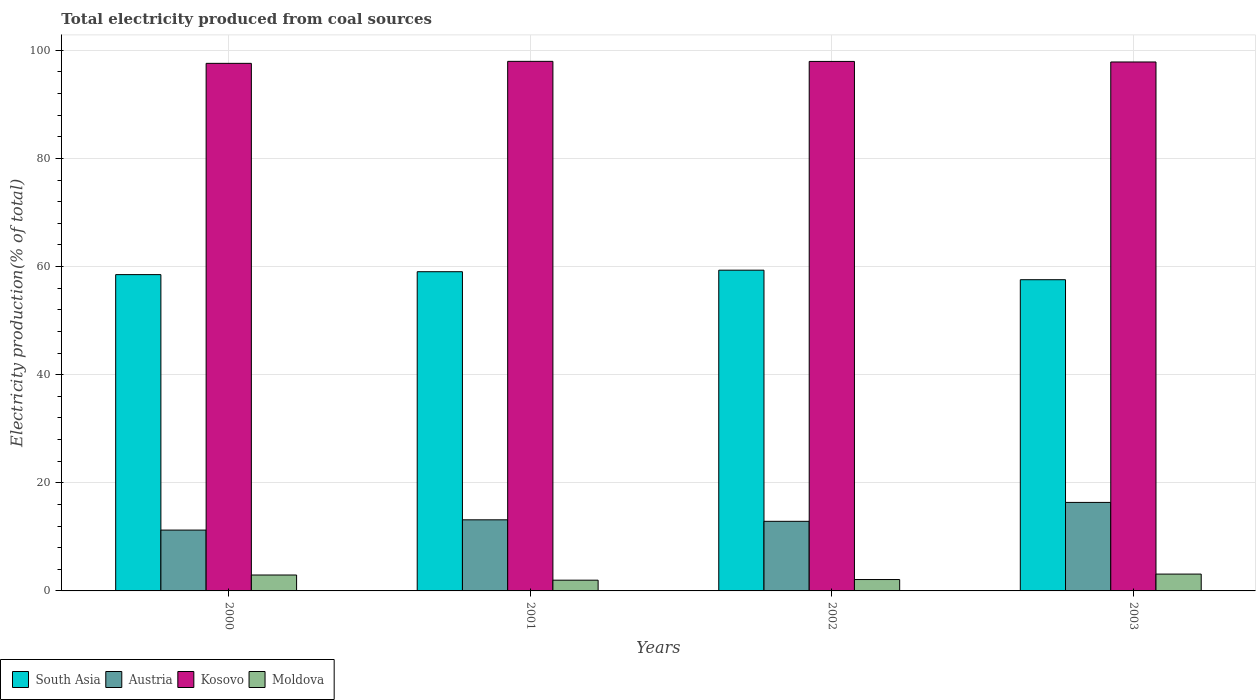How many different coloured bars are there?
Offer a terse response. 4. How many groups of bars are there?
Keep it short and to the point. 4. Are the number of bars on each tick of the X-axis equal?
Your response must be concise. Yes. How many bars are there on the 2nd tick from the left?
Provide a short and direct response. 4. How many bars are there on the 3rd tick from the right?
Offer a very short reply. 4. What is the total electricity produced in Kosovo in 2001?
Your answer should be very brief. 97.97. Across all years, what is the maximum total electricity produced in Kosovo?
Your response must be concise. 97.97. Across all years, what is the minimum total electricity produced in Moldova?
Your answer should be very brief. 1.99. In which year was the total electricity produced in Kosovo minimum?
Offer a very short reply. 2000. What is the total total electricity produced in Kosovo in the graph?
Your answer should be compact. 391.37. What is the difference between the total electricity produced in South Asia in 2000 and that in 2003?
Ensure brevity in your answer.  0.95. What is the difference between the total electricity produced in South Asia in 2003 and the total electricity produced in Austria in 2001?
Provide a short and direct response. 44.42. What is the average total electricity produced in Kosovo per year?
Keep it short and to the point. 97.84. In the year 2000, what is the difference between the total electricity produced in Kosovo and total electricity produced in South Asia?
Provide a succinct answer. 39.08. What is the ratio of the total electricity produced in Moldova in 2000 to that in 2003?
Give a very brief answer. 0.94. What is the difference between the highest and the second highest total electricity produced in South Asia?
Provide a short and direct response. 0.28. What is the difference between the highest and the lowest total electricity produced in Austria?
Make the answer very short. 5.12. In how many years, is the total electricity produced in South Asia greater than the average total electricity produced in South Asia taken over all years?
Offer a very short reply. 2. Is the sum of the total electricity produced in Austria in 2000 and 2002 greater than the maximum total electricity produced in Moldova across all years?
Your answer should be compact. Yes. Is it the case that in every year, the sum of the total electricity produced in South Asia and total electricity produced in Kosovo is greater than the sum of total electricity produced in Austria and total electricity produced in Moldova?
Your response must be concise. Yes. What does the 1st bar from the right in 2003 represents?
Ensure brevity in your answer.  Moldova. What is the difference between two consecutive major ticks on the Y-axis?
Offer a terse response. 20. Are the values on the major ticks of Y-axis written in scientific E-notation?
Your answer should be very brief. No. Does the graph contain any zero values?
Your answer should be compact. No. Where does the legend appear in the graph?
Provide a short and direct response. Bottom left. What is the title of the graph?
Make the answer very short. Total electricity produced from coal sources. What is the label or title of the X-axis?
Offer a very short reply. Years. What is the label or title of the Y-axis?
Provide a succinct answer. Electricity production(% of total). What is the Electricity production(% of total) of South Asia in 2000?
Give a very brief answer. 58.52. What is the Electricity production(% of total) of Austria in 2000?
Offer a terse response. 11.26. What is the Electricity production(% of total) of Kosovo in 2000?
Provide a short and direct response. 97.6. What is the Electricity production(% of total) in Moldova in 2000?
Provide a short and direct response. 2.94. What is the Electricity production(% of total) in South Asia in 2001?
Keep it short and to the point. 59.05. What is the Electricity production(% of total) of Austria in 2001?
Offer a terse response. 13.15. What is the Electricity production(% of total) of Kosovo in 2001?
Give a very brief answer. 97.97. What is the Electricity production(% of total) in Moldova in 2001?
Your response must be concise. 1.99. What is the Electricity production(% of total) of South Asia in 2002?
Give a very brief answer. 59.33. What is the Electricity production(% of total) of Austria in 2002?
Give a very brief answer. 12.88. What is the Electricity production(% of total) of Kosovo in 2002?
Your response must be concise. 97.95. What is the Electricity production(% of total) of Moldova in 2002?
Keep it short and to the point. 2.11. What is the Electricity production(% of total) in South Asia in 2003?
Offer a very short reply. 57.57. What is the Electricity production(% of total) in Austria in 2003?
Ensure brevity in your answer.  16.37. What is the Electricity production(% of total) of Kosovo in 2003?
Your answer should be very brief. 97.85. What is the Electricity production(% of total) of Moldova in 2003?
Keep it short and to the point. 3.12. Across all years, what is the maximum Electricity production(% of total) in South Asia?
Offer a very short reply. 59.33. Across all years, what is the maximum Electricity production(% of total) of Austria?
Provide a succinct answer. 16.37. Across all years, what is the maximum Electricity production(% of total) in Kosovo?
Your answer should be very brief. 97.97. Across all years, what is the maximum Electricity production(% of total) of Moldova?
Your response must be concise. 3.12. Across all years, what is the minimum Electricity production(% of total) of South Asia?
Make the answer very short. 57.57. Across all years, what is the minimum Electricity production(% of total) of Austria?
Make the answer very short. 11.26. Across all years, what is the minimum Electricity production(% of total) of Kosovo?
Your response must be concise. 97.6. Across all years, what is the minimum Electricity production(% of total) in Moldova?
Ensure brevity in your answer.  1.99. What is the total Electricity production(% of total) in South Asia in the graph?
Make the answer very short. 234.48. What is the total Electricity production(% of total) of Austria in the graph?
Keep it short and to the point. 53.66. What is the total Electricity production(% of total) in Kosovo in the graph?
Your response must be concise. 391.37. What is the total Electricity production(% of total) in Moldova in the graph?
Give a very brief answer. 10.15. What is the difference between the Electricity production(% of total) in South Asia in 2000 and that in 2001?
Keep it short and to the point. -0.54. What is the difference between the Electricity production(% of total) in Austria in 2000 and that in 2001?
Offer a terse response. -1.9. What is the difference between the Electricity production(% of total) in Kosovo in 2000 and that in 2001?
Provide a short and direct response. -0.37. What is the difference between the Electricity production(% of total) in South Asia in 2000 and that in 2002?
Give a very brief answer. -0.82. What is the difference between the Electricity production(% of total) of Austria in 2000 and that in 2002?
Provide a short and direct response. -1.62. What is the difference between the Electricity production(% of total) in Kosovo in 2000 and that in 2002?
Make the answer very short. -0.36. What is the difference between the Electricity production(% of total) of Moldova in 2000 and that in 2002?
Your answer should be very brief. 0.84. What is the difference between the Electricity production(% of total) in South Asia in 2000 and that in 2003?
Provide a succinct answer. 0.95. What is the difference between the Electricity production(% of total) of Austria in 2000 and that in 2003?
Make the answer very short. -5.12. What is the difference between the Electricity production(% of total) in Kosovo in 2000 and that in 2003?
Ensure brevity in your answer.  -0.25. What is the difference between the Electricity production(% of total) in Moldova in 2000 and that in 2003?
Offer a very short reply. -0.17. What is the difference between the Electricity production(% of total) of South Asia in 2001 and that in 2002?
Ensure brevity in your answer.  -0.28. What is the difference between the Electricity production(% of total) in Austria in 2001 and that in 2002?
Provide a short and direct response. 0.28. What is the difference between the Electricity production(% of total) in Kosovo in 2001 and that in 2002?
Your answer should be very brief. 0.01. What is the difference between the Electricity production(% of total) of Moldova in 2001 and that in 2002?
Provide a succinct answer. -0.12. What is the difference between the Electricity production(% of total) in South Asia in 2001 and that in 2003?
Offer a terse response. 1.48. What is the difference between the Electricity production(% of total) of Austria in 2001 and that in 2003?
Offer a very short reply. -3.22. What is the difference between the Electricity production(% of total) in Kosovo in 2001 and that in 2003?
Offer a very short reply. 0.12. What is the difference between the Electricity production(% of total) in Moldova in 2001 and that in 2003?
Your answer should be very brief. -1.13. What is the difference between the Electricity production(% of total) of South Asia in 2002 and that in 2003?
Give a very brief answer. 1.76. What is the difference between the Electricity production(% of total) of Austria in 2002 and that in 2003?
Keep it short and to the point. -3.5. What is the difference between the Electricity production(% of total) in Kosovo in 2002 and that in 2003?
Keep it short and to the point. 0.1. What is the difference between the Electricity production(% of total) in Moldova in 2002 and that in 2003?
Provide a succinct answer. -1.01. What is the difference between the Electricity production(% of total) in South Asia in 2000 and the Electricity production(% of total) in Austria in 2001?
Give a very brief answer. 45.36. What is the difference between the Electricity production(% of total) in South Asia in 2000 and the Electricity production(% of total) in Kosovo in 2001?
Make the answer very short. -39.45. What is the difference between the Electricity production(% of total) in South Asia in 2000 and the Electricity production(% of total) in Moldova in 2001?
Offer a very short reply. 56.53. What is the difference between the Electricity production(% of total) of Austria in 2000 and the Electricity production(% of total) of Kosovo in 2001?
Give a very brief answer. -86.71. What is the difference between the Electricity production(% of total) of Austria in 2000 and the Electricity production(% of total) of Moldova in 2001?
Keep it short and to the point. 9.27. What is the difference between the Electricity production(% of total) in Kosovo in 2000 and the Electricity production(% of total) in Moldova in 2001?
Give a very brief answer. 95.61. What is the difference between the Electricity production(% of total) in South Asia in 2000 and the Electricity production(% of total) in Austria in 2002?
Provide a short and direct response. 45.64. What is the difference between the Electricity production(% of total) in South Asia in 2000 and the Electricity production(% of total) in Kosovo in 2002?
Your answer should be very brief. -39.44. What is the difference between the Electricity production(% of total) of South Asia in 2000 and the Electricity production(% of total) of Moldova in 2002?
Provide a succinct answer. 56.41. What is the difference between the Electricity production(% of total) of Austria in 2000 and the Electricity production(% of total) of Kosovo in 2002?
Keep it short and to the point. -86.7. What is the difference between the Electricity production(% of total) of Austria in 2000 and the Electricity production(% of total) of Moldova in 2002?
Your response must be concise. 9.15. What is the difference between the Electricity production(% of total) of Kosovo in 2000 and the Electricity production(% of total) of Moldova in 2002?
Give a very brief answer. 95.49. What is the difference between the Electricity production(% of total) in South Asia in 2000 and the Electricity production(% of total) in Austria in 2003?
Your response must be concise. 42.14. What is the difference between the Electricity production(% of total) in South Asia in 2000 and the Electricity production(% of total) in Kosovo in 2003?
Provide a succinct answer. -39.34. What is the difference between the Electricity production(% of total) in South Asia in 2000 and the Electricity production(% of total) in Moldova in 2003?
Keep it short and to the point. 55.4. What is the difference between the Electricity production(% of total) of Austria in 2000 and the Electricity production(% of total) of Kosovo in 2003?
Give a very brief answer. -86.6. What is the difference between the Electricity production(% of total) in Austria in 2000 and the Electricity production(% of total) in Moldova in 2003?
Provide a short and direct response. 8.14. What is the difference between the Electricity production(% of total) of Kosovo in 2000 and the Electricity production(% of total) of Moldova in 2003?
Ensure brevity in your answer.  94.48. What is the difference between the Electricity production(% of total) of South Asia in 2001 and the Electricity production(% of total) of Austria in 2002?
Your response must be concise. 46.18. What is the difference between the Electricity production(% of total) in South Asia in 2001 and the Electricity production(% of total) in Kosovo in 2002?
Keep it short and to the point. -38.9. What is the difference between the Electricity production(% of total) in South Asia in 2001 and the Electricity production(% of total) in Moldova in 2002?
Offer a very short reply. 56.95. What is the difference between the Electricity production(% of total) of Austria in 2001 and the Electricity production(% of total) of Kosovo in 2002?
Ensure brevity in your answer.  -84.8. What is the difference between the Electricity production(% of total) of Austria in 2001 and the Electricity production(% of total) of Moldova in 2002?
Provide a succinct answer. 11.05. What is the difference between the Electricity production(% of total) in Kosovo in 2001 and the Electricity production(% of total) in Moldova in 2002?
Offer a very short reply. 95.86. What is the difference between the Electricity production(% of total) of South Asia in 2001 and the Electricity production(% of total) of Austria in 2003?
Keep it short and to the point. 42.68. What is the difference between the Electricity production(% of total) in South Asia in 2001 and the Electricity production(% of total) in Kosovo in 2003?
Ensure brevity in your answer.  -38.8. What is the difference between the Electricity production(% of total) of South Asia in 2001 and the Electricity production(% of total) of Moldova in 2003?
Offer a very short reply. 55.94. What is the difference between the Electricity production(% of total) in Austria in 2001 and the Electricity production(% of total) in Kosovo in 2003?
Offer a very short reply. -84.7. What is the difference between the Electricity production(% of total) in Austria in 2001 and the Electricity production(% of total) in Moldova in 2003?
Make the answer very short. 10.04. What is the difference between the Electricity production(% of total) of Kosovo in 2001 and the Electricity production(% of total) of Moldova in 2003?
Your answer should be compact. 94.85. What is the difference between the Electricity production(% of total) in South Asia in 2002 and the Electricity production(% of total) in Austria in 2003?
Keep it short and to the point. 42.96. What is the difference between the Electricity production(% of total) in South Asia in 2002 and the Electricity production(% of total) in Kosovo in 2003?
Offer a very short reply. -38.52. What is the difference between the Electricity production(% of total) of South Asia in 2002 and the Electricity production(% of total) of Moldova in 2003?
Keep it short and to the point. 56.22. What is the difference between the Electricity production(% of total) of Austria in 2002 and the Electricity production(% of total) of Kosovo in 2003?
Give a very brief answer. -84.97. What is the difference between the Electricity production(% of total) in Austria in 2002 and the Electricity production(% of total) in Moldova in 2003?
Give a very brief answer. 9.76. What is the difference between the Electricity production(% of total) of Kosovo in 2002 and the Electricity production(% of total) of Moldova in 2003?
Your answer should be very brief. 94.84. What is the average Electricity production(% of total) of South Asia per year?
Make the answer very short. 58.62. What is the average Electricity production(% of total) of Austria per year?
Your answer should be compact. 13.41. What is the average Electricity production(% of total) of Kosovo per year?
Ensure brevity in your answer.  97.84. What is the average Electricity production(% of total) in Moldova per year?
Your response must be concise. 2.54. In the year 2000, what is the difference between the Electricity production(% of total) in South Asia and Electricity production(% of total) in Austria?
Your response must be concise. 47.26. In the year 2000, what is the difference between the Electricity production(% of total) in South Asia and Electricity production(% of total) in Kosovo?
Offer a terse response. -39.08. In the year 2000, what is the difference between the Electricity production(% of total) in South Asia and Electricity production(% of total) in Moldova?
Ensure brevity in your answer.  55.57. In the year 2000, what is the difference between the Electricity production(% of total) of Austria and Electricity production(% of total) of Kosovo?
Your response must be concise. -86.34. In the year 2000, what is the difference between the Electricity production(% of total) of Austria and Electricity production(% of total) of Moldova?
Offer a terse response. 8.31. In the year 2000, what is the difference between the Electricity production(% of total) of Kosovo and Electricity production(% of total) of Moldova?
Keep it short and to the point. 94.66. In the year 2001, what is the difference between the Electricity production(% of total) in South Asia and Electricity production(% of total) in Austria?
Make the answer very short. 45.9. In the year 2001, what is the difference between the Electricity production(% of total) of South Asia and Electricity production(% of total) of Kosovo?
Give a very brief answer. -38.91. In the year 2001, what is the difference between the Electricity production(% of total) of South Asia and Electricity production(% of total) of Moldova?
Keep it short and to the point. 57.07. In the year 2001, what is the difference between the Electricity production(% of total) in Austria and Electricity production(% of total) in Kosovo?
Offer a terse response. -84.81. In the year 2001, what is the difference between the Electricity production(% of total) of Austria and Electricity production(% of total) of Moldova?
Ensure brevity in your answer.  11.17. In the year 2001, what is the difference between the Electricity production(% of total) of Kosovo and Electricity production(% of total) of Moldova?
Ensure brevity in your answer.  95.98. In the year 2002, what is the difference between the Electricity production(% of total) of South Asia and Electricity production(% of total) of Austria?
Your response must be concise. 46.46. In the year 2002, what is the difference between the Electricity production(% of total) in South Asia and Electricity production(% of total) in Kosovo?
Offer a terse response. -38.62. In the year 2002, what is the difference between the Electricity production(% of total) of South Asia and Electricity production(% of total) of Moldova?
Provide a short and direct response. 57.23. In the year 2002, what is the difference between the Electricity production(% of total) in Austria and Electricity production(% of total) in Kosovo?
Make the answer very short. -85.08. In the year 2002, what is the difference between the Electricity production(% of total) of Austria and Electricity production(% of total) of Moldova?
Your answer should be very brief. 10.77. In the year 2002, what is the difference between the Electricity production(% of total) of Kosovo and Electricity production(% of total) of Moldova?
Offer a terse response. 95.85. In the year 2003, what is the difference between the Electricity production(% of total) of South Asia and Electricity production(% of total) of Austria?
Offer a very short reply. 41.2. In the year 2003, what is the difference between the Electricity production(% of total) of South Asia and Electricity production(% of total) of Kosovo?
Your answer should be very brief. -40.28. In the year 2003, what is the difference between the Electricity production(% of total) in South Asia and Electricity production(% of total) in Moldova?
Offer a very short reply. 54.46. In the year 2003, what is the difference between the Electricity production(% of total) in Austria and Electricity production(% of total) in Kosovo?
Your answer should be very brief. -81.48. In the year 2003, what is the difference between the Electricity production(% of total) in Austria and Electricity production(% of total) in Moldova?
Your answer should be very brief. 13.26. In the year 2003, what is the difference between the Electricity production(% of total) of Kosovo and Electricity production(% of total) of Moldova?
Provide a succinct answer. 94.74. What is the ratio of the Electricity production(% of total) of South Asia in 2000 to that in 2001?
Provide a succinct answer. 0.99. What is the ratio of the Electricity production(% of total) of Austria in 2000 to that in 2001?
Make the answer very short. 0.86. What is the ratio of the Electricity production(% of total) of Moldova in 2000 to that in 2001?
Provide a short and direct response. 1.48. What is the ratio of the Electricity production(% of total) of South Asia in 2000 to that in 2002?
Keep it short and to the point. 0.99. What is the ratio of the Electricity production(% of total) of Austria in 2000 to that in 2002?
Keep it short and to the point. 0.87. What is the ratio of the Electricity production(% of total) in Kosovo in 2000 to that in 2002?
Offer a terse response. 1. What is the ratio of the Electricity production(% of total) of Moldova in 2000 to that in 2002?
Your answer should be very brief. 1.4. What is the ratio of the Electricity production(% of total) in South Asia in 2000 to that in 2003?
Your answer should be very brief. 1.02. What is the ratio of the Electricity production(% of total) in Austria in 2000 to that in 2003?
Offer a very short reply. 0.69. What is the ratio of the Electricity production(% of total) of Moldova in 2000 to that in 2003?
Keep it short and to the point. 0.94. What is the ratio of the Electricity production(% of total) of South Asia in 2001 to that in 2002?
Make the answer very short. 1. What is the ratio of the Electricity production(% of total) of Austria in 2001 to that in 2002?
Offer a terse response. 1.02. What is the ratio of the Electricity production(% of total) in Kosovo in 2001 to that in 2002?
Keep it short and to the point. 1. What is the ratio of the Electricity production(% of total) of Moldova in 2001 to that in 2002?
Your response must be concise. 0.94. What is the ratio of the Electricity production(% of total) of South Asia in 2001 to that in 2003?
Provide a succinct answer. 1.03. What is the ratio of the Electricity production(% of total) in Austria in 2001 to that in 2003?
Keep it short and to the point. 0.8. What is the ratio of the Electricity production(% of total) in Moldova in 2001 to that in 2003?
Provide a short and direct response. 0.64. What is the ratio of the Electricity production(% of total) in South Asia in 2002 to that in 2003?
Offer a terse response. 1.03. What is the ratio of the Electricity production(% of total) of Austria in 2002 to that in 2003?
Make the answer very short. 0.79. What is the ratio of the Electricity production(% of total) in Kosovo in 2002 to that in 2003?
Ensure brevity in your answer.  1. What is the ratio of the Electricity production(% of total) in Moldova in 2002 to that in 2003?
Offer a terse response. 0.68. What is the difference between the highest and the second highest Electricity production(% of total) in South Asia?
Give a very brief answer. 0.28. What is the difference between the highest and the second highest Electricity production(% of total) in Austria?
Make the answer very short. 3.22. What is the difference between the highest and the second highest Electricity production(% of total) of Kosovo?
Ensure brevity in your answer.  0.01. What is the difference between the highest and the second highest Electricity production(% of total) in Moldova?
Ensure brevity in your answer.  0.17. What is the difference between the highest and the lowest Electricity production(% of total) in South Asia?
Provide a short and direct response. 1.76. What is the difference between the highest and the lowest Electricity production(% of total) of Austria?
Provide a short and direct response. 5.12. What is the difference between the highest and the lowest Electricity production(% of total) in Kosovo?
Offer a very short reply. 0.37. What is the difference between the highest and the lowest Electricity production(% of total) in Moldova?
Keep it short and to the point. 1.13. 